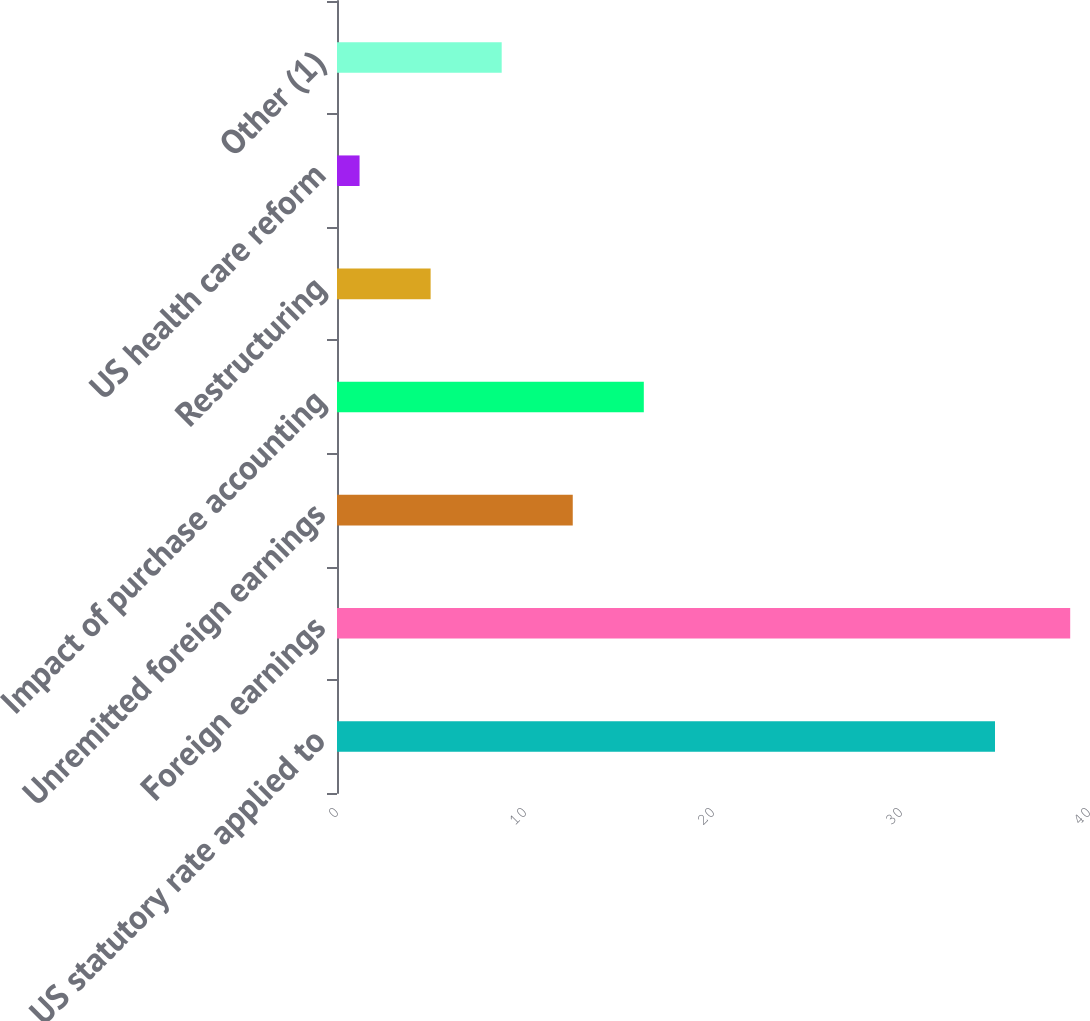Convert chart to OTSL. <chart><loc_0><loc_0><loc_500><loc_500><bar_chart><fcel>US statutory rate applied to<fcel>Foreign earnings<fcel>Unremitted foreign earnings<fcel>Impact of purchase accounting<fcel>Restructuring<fcel>US health care reform<fcel>Other (1)<nl><fcel>35<fcel>39<fcel>12.54<fcel>16.32<fcel>4.98<fcel>1.2<fcel>8.76<nl></chart> 